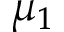Convert formula to latex. <formula><loc_0><loc_0><loc_500><loc_500>\mu _ { 1 }</formula> 